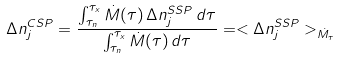<formula> <loc_0><loc_0><loc_500><loc_500>\Delta n _ { j } ^ { C S P } = \frac { \int _ { \tau _ { n } } ^ { \tau _ { x } } \dot { M } ( \tau ) \, \Delta n _ { j } ^ { S S P } \, d \tau } { \int _ { \tau _ { n } } ^ { \tau _ { x } } \dot { M } ( \tau ) \, d \tau } = < \Delta n _ { j } ^ { S S P } > _ { \dot { M } _ { \tau } }</formula> 